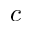Convert formula to latex. <formula><loc_0><loc_0><loc_500><loc_500>c</formula> 